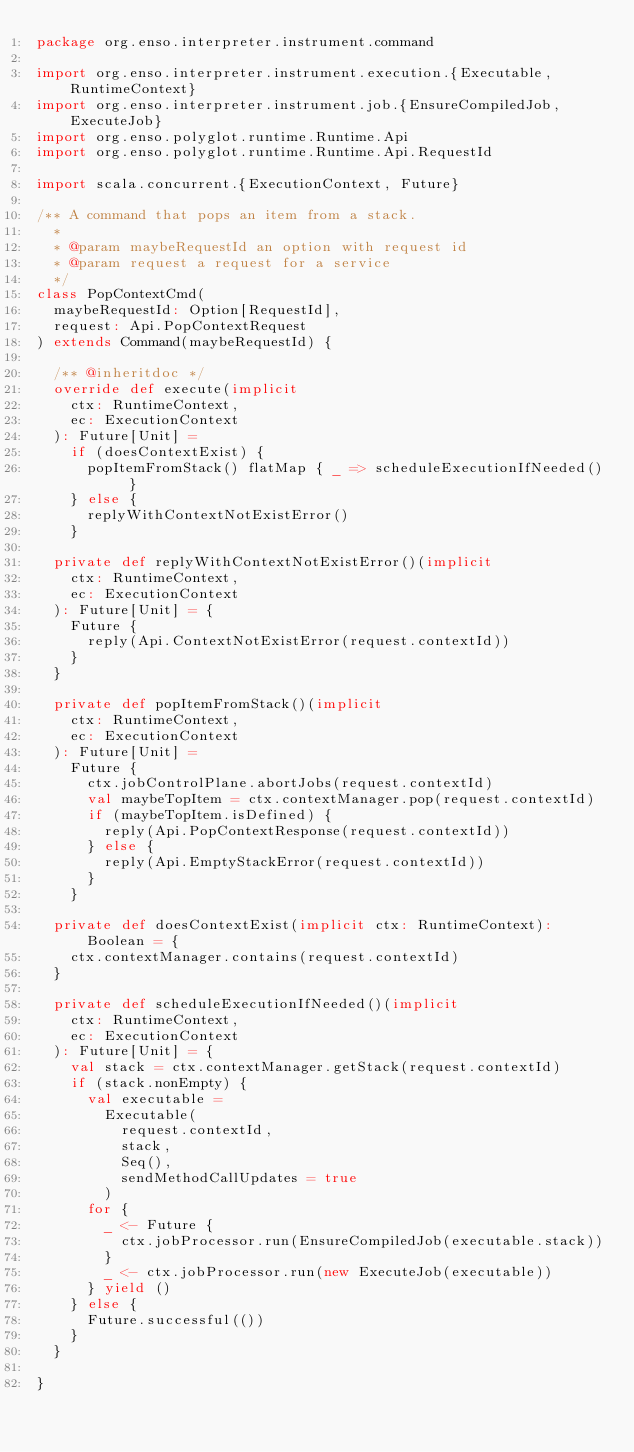Convert code to text. <code><loc_0><loc_0><loc_500><loc_500><_Scala_>package org.enso.interpreter.instrument.command

import org.enso.interpreter.instrument.execution.{Executable, RuntimeContext}
import org.enso.interpreter.instrument.job.{EnsureCompiledJob, ExecuteJob}
import org.enso.polyglot.runtime.Runtime.Api
import org.enso.polyglot.runtime.Runtime.Api.RequestId

import scala.concurrent.{ExecutionContext, Future}

/** A command that pops an item from a stack.
  *
  * @param maybeRequestId an option with request id
  * @param request a request for a service
  */
class PopContextCmd(
  maybeRequestId: Option[RequestId],
  request: Api.PopContextRequest
) extends Command(maybeRequestId) {

  /** @inheritdoc */
  override def execute(implicit
    ctx: RuntimeContext,
    ec: ExecutionContext
  ): Future[Unit] =
    if (doesContextExist) {
      popItemFromStack() flatMap { _ => scheduleExecutionIfNeeded() }
    } else {
      replyWithContextNotExistError()
    }

  private def replyWithContextNotExistError()(implicit
    ctx: RuntimeContext,
    ec: ExecutionContext
  ): Future[Unit] = {
    Future {
      reply(Api.ContextNotExistError(request.contextId))
    }
  }

  private def popItemFromStack()(implicit
    ctx: RuntimeContext,
    ec: ExecutionContext
  ): Future[Unit] =
    Future {
      ctx.jobControlPlane.abortJobs(request.contextId)
      val maybeTopItem = ctx.contextManager.pop(request.contextId)
      if (maybeTopItem.isDefined) {
        reply(Api.PopContextResponse(request.contextId))
      } else {
        reply(Api.EmptyStackError(request.contextId))
      }
    }

  private def doesContextExist(implicit ctx: RuntimeContext): Boolean = {
    ctx.contextManager.contains(request.contextId)
  }

  private def scheduleExecutionIfNeeded()(implicit
    ctx: RuntimeContext,
    ec: ExecutionContext
  ): Future[Unit] = {
    val stack = ctx.contextManager.getStack(request.contextId)
    if (stack.nonEmpty) {
      val executable =
        Executable(
          request.contextId,
          stack,
          Seq(),
          sendMethodCallUpdates = true
        )
      for {
        _ <- Future {
          ctx.jobProcessor.run(EnsureCompiledJob(executable.stack))
        }
        _ <- ctx.jobProcessor.run(new ExecuteJob(executable))
      } yield ()
    } else {
      Future.successful(())
    }
  }

}
</code> 